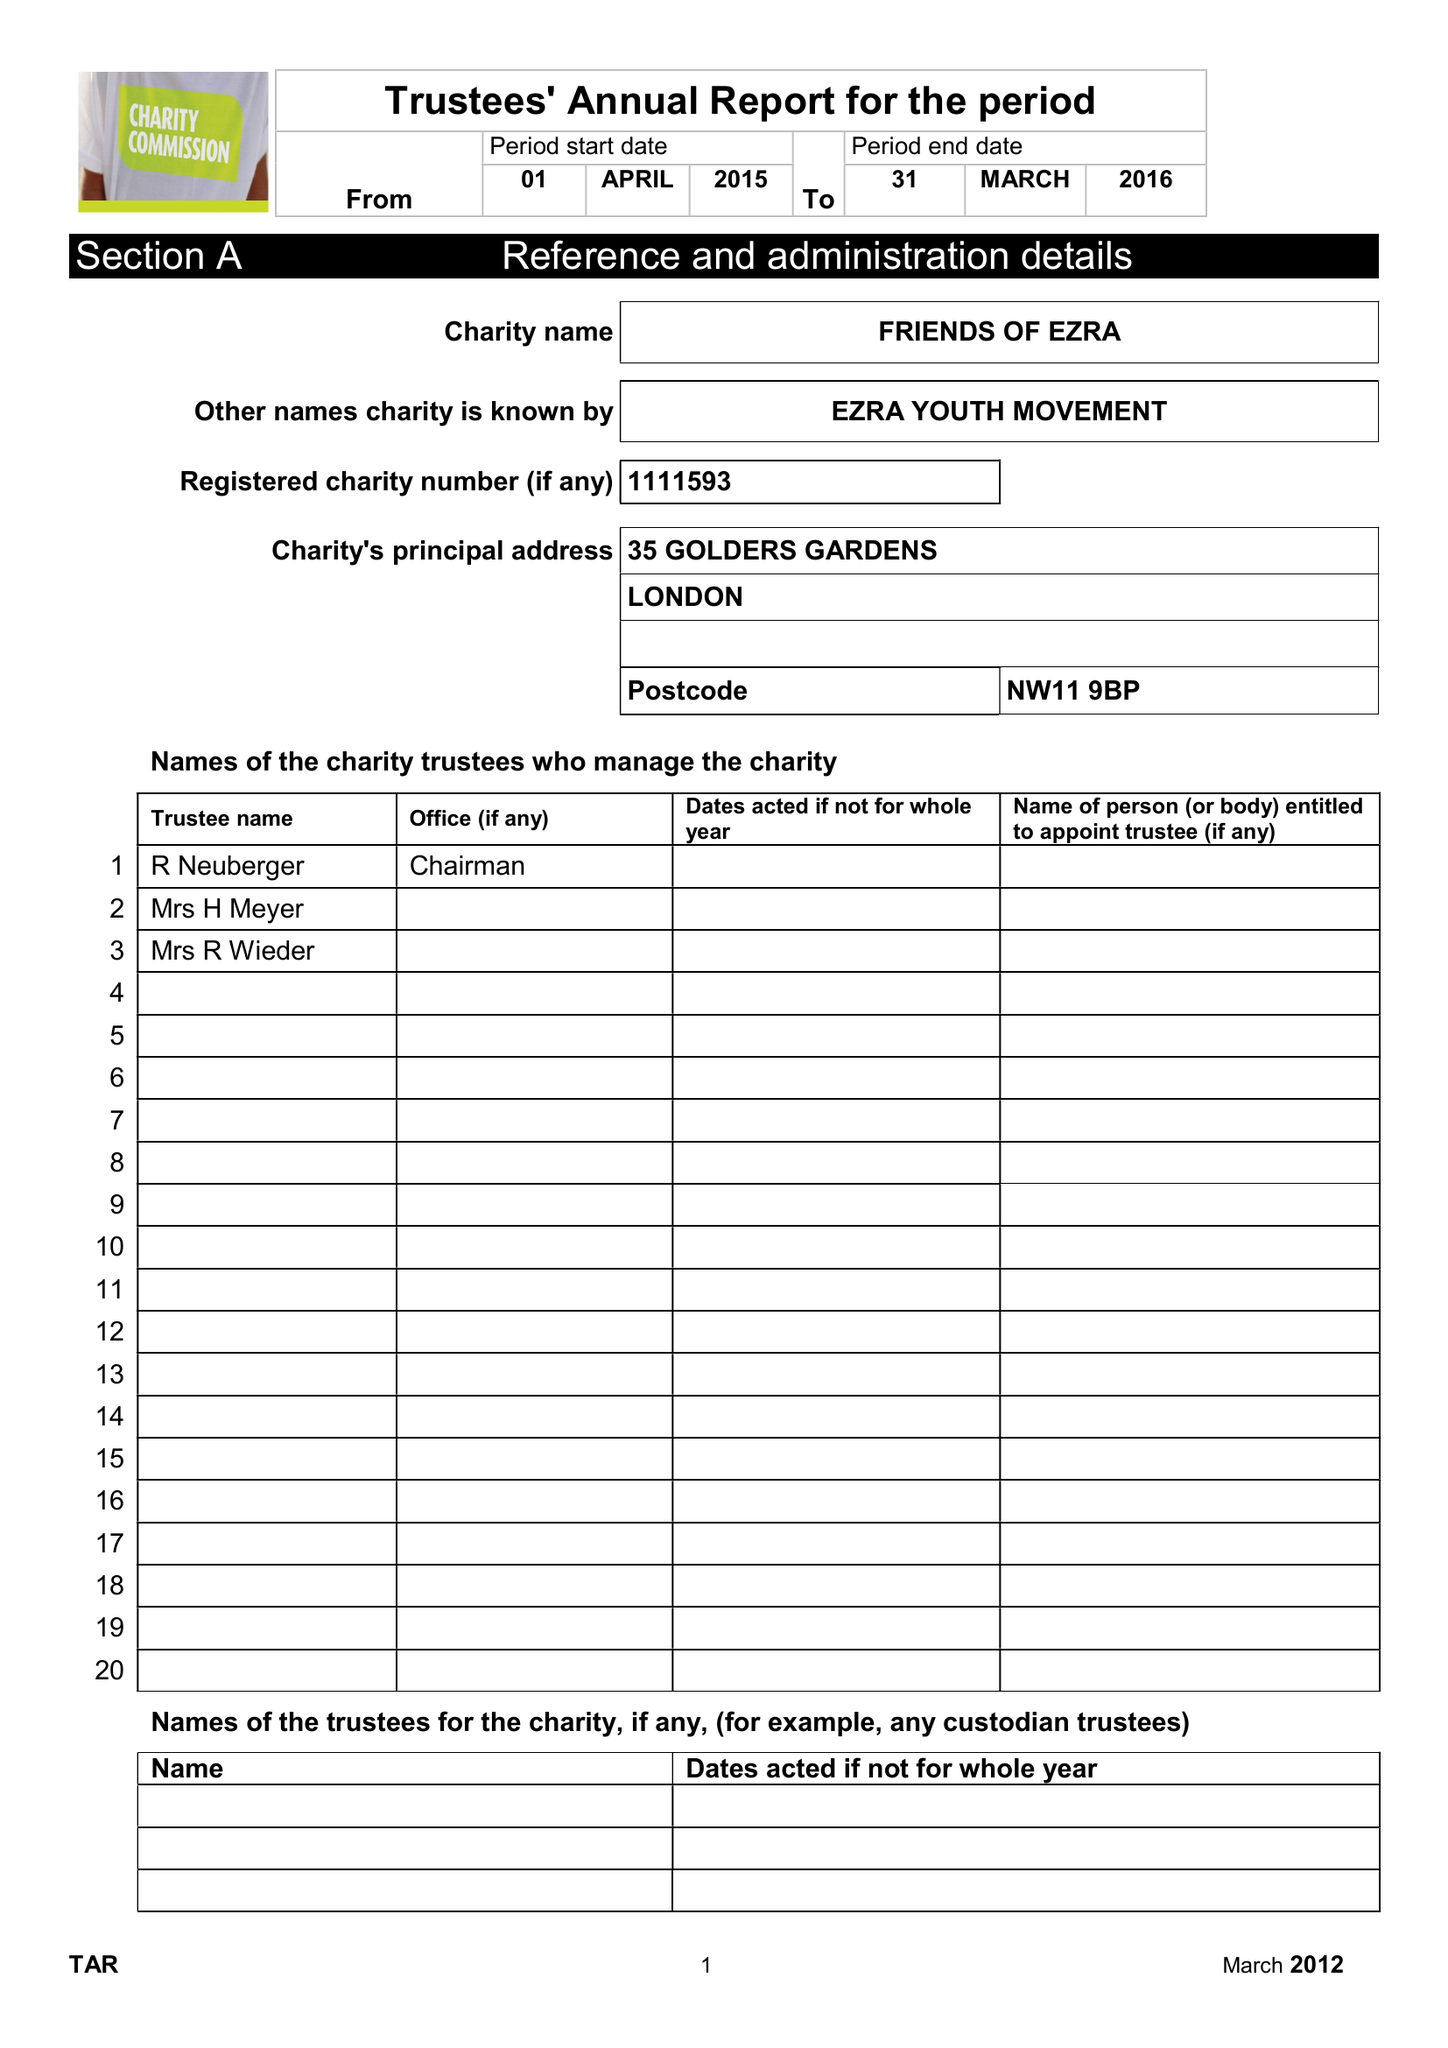What is the value for the address__street_line?
Answer the question using a single word or phrase. 35 GOLDERS GARDENS 